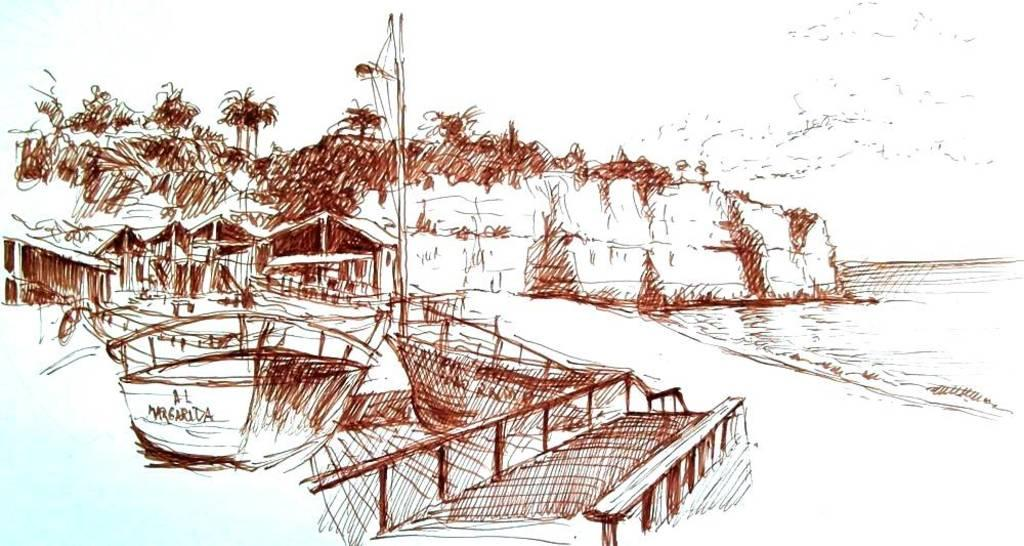What type of art piece is depicted in the image? The image is an art piece near a sea shore. What can be seen in the background of the image? There are homes visible in the background, and trees are present behind the homes on a hill. What is visible in the front of the image? Boats are visible in the front of the image, and there is sand in the front as well. What part of the image appears to depict a beach? The right side of the image appears to depict a beach. What type of meal is being prepared on the beach in the image? There is no meal being prepared in the image; it is an art piece depicting a sea shore with homes, trees, boats, sand, and a beach. Can you see any crayons being used to draw on the sand in the image? There are no crayons or any drawing activity visible in the image. 